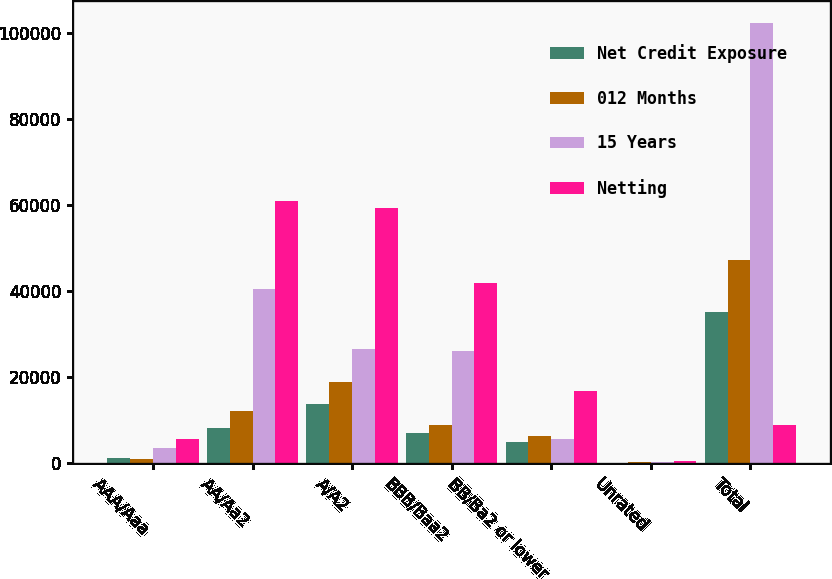<chart> <loc_0><loc_0><loc_500><loc_500><stacked_bar_chart><ecel><fcel>AAA/Aaa<fcel>AA/Aa2<fcel>A/A2<fcel>BBB/Baa2<fcel>BB/Ba2 or lower<fcel>Unrated<fcel>Total<nl><fcel>Net Credit Exposure<fcel>1119<fcel>8260<fcel>13719<fcel>7049<fcel>4959<fcel>79<fcel>35185<nl><fcel>012 Months<fcel>898<fcel>12182<fcel>18949<fcel>8758<fcel>6226<fcel>363<fcel>47376<nl><fcel>15 Years<fcel>3500<fcel>40443<fcel>26649<fcel>26087<fcel>5660<fcel>160<fcel>102499<nl><fcel>Netting<fcel>5517<fcel>60885<fcel>59317<fcel>41894<fcel>16845<fcel>602<fcel>8758<nl></chart> 